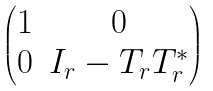Convert formula to latex. <formula><loc_0><loc_0><loc_500><loc_500>\begin{pmatrix} 1 & 0 \\ 0 & I _ { r } - T _ { r } T _ { r } ^ { * } \end{pmatrix}</formula> 